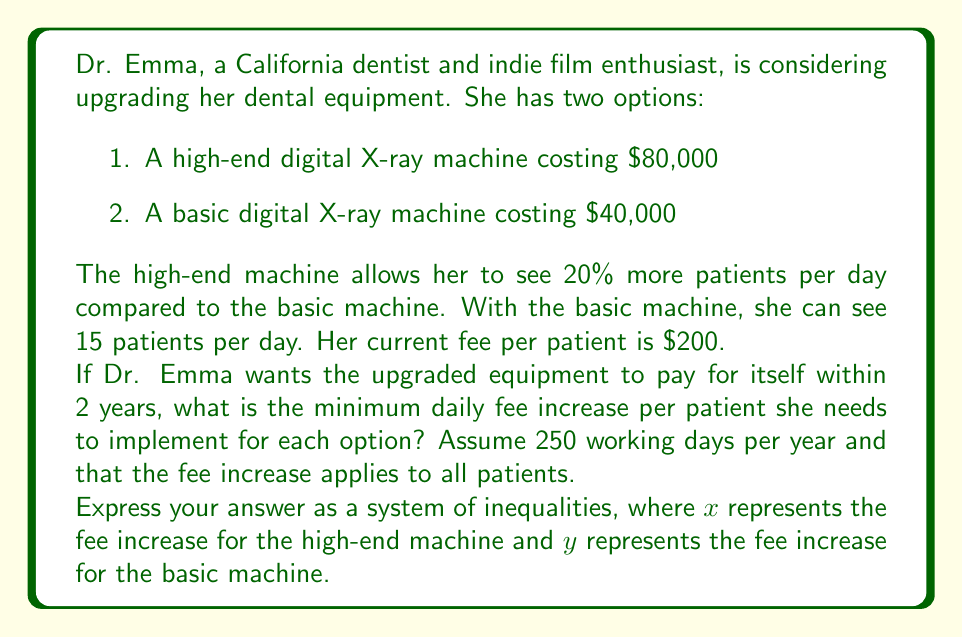Provide a solution to this math problem. Let's approach this step-by-step:

1) First, let's calculate the number of patients Dr. Emma can see with each machine:
   - Basic machine: 15 patients/day
   - High-end machine: 15 * 1.20 = 18 patients/day

2) Now, let's set up inequalities for each machine. The total additional revenue over 2 years should be greater than or equal to the cost of the machine.

3) For the high-end machine ($80,000):
   $$(18 * (200 + x) - 18 * 200) * 250 * 2 \geq 80000$$
   Simplifying: $$9000x \geq 80000$$

4) For the basic machine ($40,000):
   $$(15 * (200 + y) - 15 * 200) * 250 * 2 \geq 40000$$
   Simplifying: $$7500y \geq 40000$$

5) Solving these inequalities:
   For x: $$x \geq \frac{80000}{9000} = \frac{8}{9} \approx 8.89$$
   For y: $$y \geq \frac{40000}{7500} = \frac{16}{3} \approx 5.33$$

6) Since we're looking for the minimum fee increase, we can use ≥ instead of > in our final system of inequalities.
Answer: The system of inequalities representing the minimum daily fee increase per patient for each option is:

$$\begin{cases}
x \geq \frac{8}{9} \\
y \geq \frac{16}{3}
\end{cases}$$

Where $x$ is the fee increase for the high-end machine and $y$ is the fee increase for the basic machine, both in dollars. 